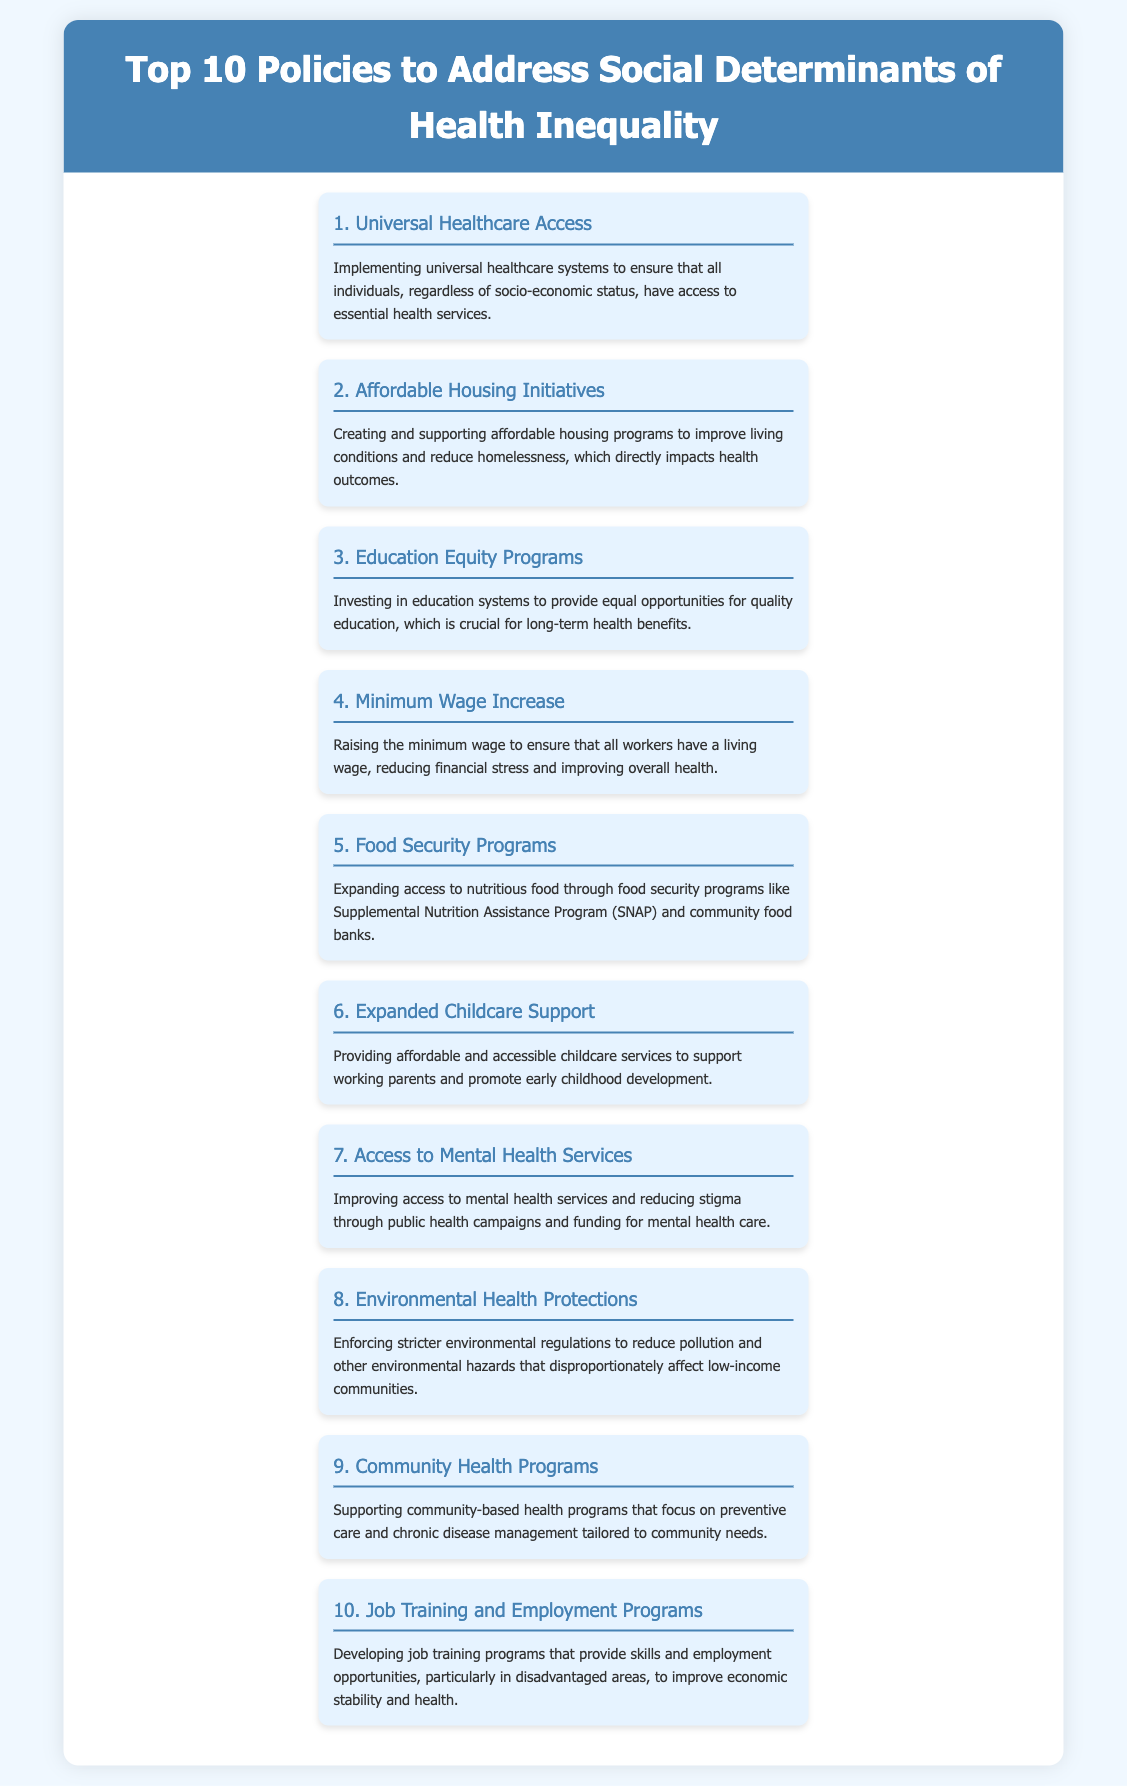What is the title of the document? The title is displayed prominently at the top of the document.
Answer: Top 10 Policies to Address Social Determinants of Health Inequality What policy is number 3 on the list? The document lists policies in order, and number 3 is specified in the list.
Answer: Education Equity Programs How many policies are listed in total? The document indicates a specific count of policies included.
Answer: 10 Which policy focuses on mental health services? The document provides the titles of policies addressing specific issues.
Answer: Access to Mental Health Services What is the focus of the second policy? The second policy's description directly notes its primary concern.
Answer: Affordable Housing Initiatives Which social determinant does the fifth policy address? The fifth policy specifically mentions improving access to a type of resource.
Answer: Food Security How does the fourth policy aim to improve health? The description provides insight into the economic aspect of the policy.
Answer: Raising the minimum wage What does the tenth policy promote? The tenth policy clearly indicates its goal in the title and description.
Answer: Job training and employment programs What issue does the eighth policy deal with? The description explains the environmental focus of the policy.
Answer: Environmental health protections 